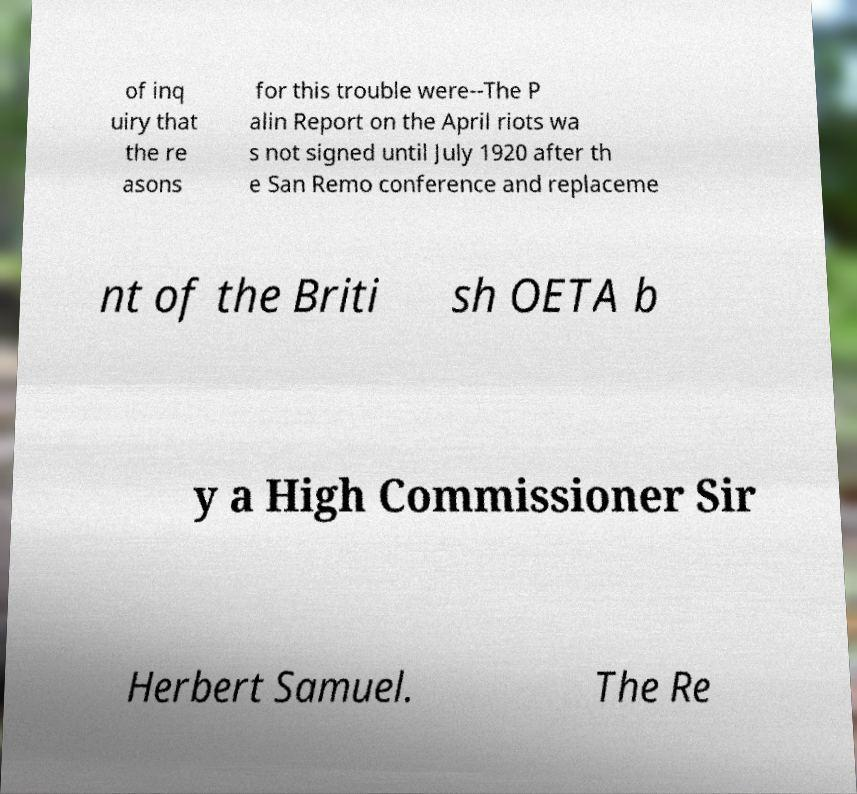Please read and relay the text visible in this image. What does it say? of inq uiry that the re asons for this trouble were--The P alin Report on the April riots wa s not signed until July 1920 after th e San Remo conference and replaceme nt of the Briti sh OETA b y a High Commissioner Sir Herbert Samuel. The Re 